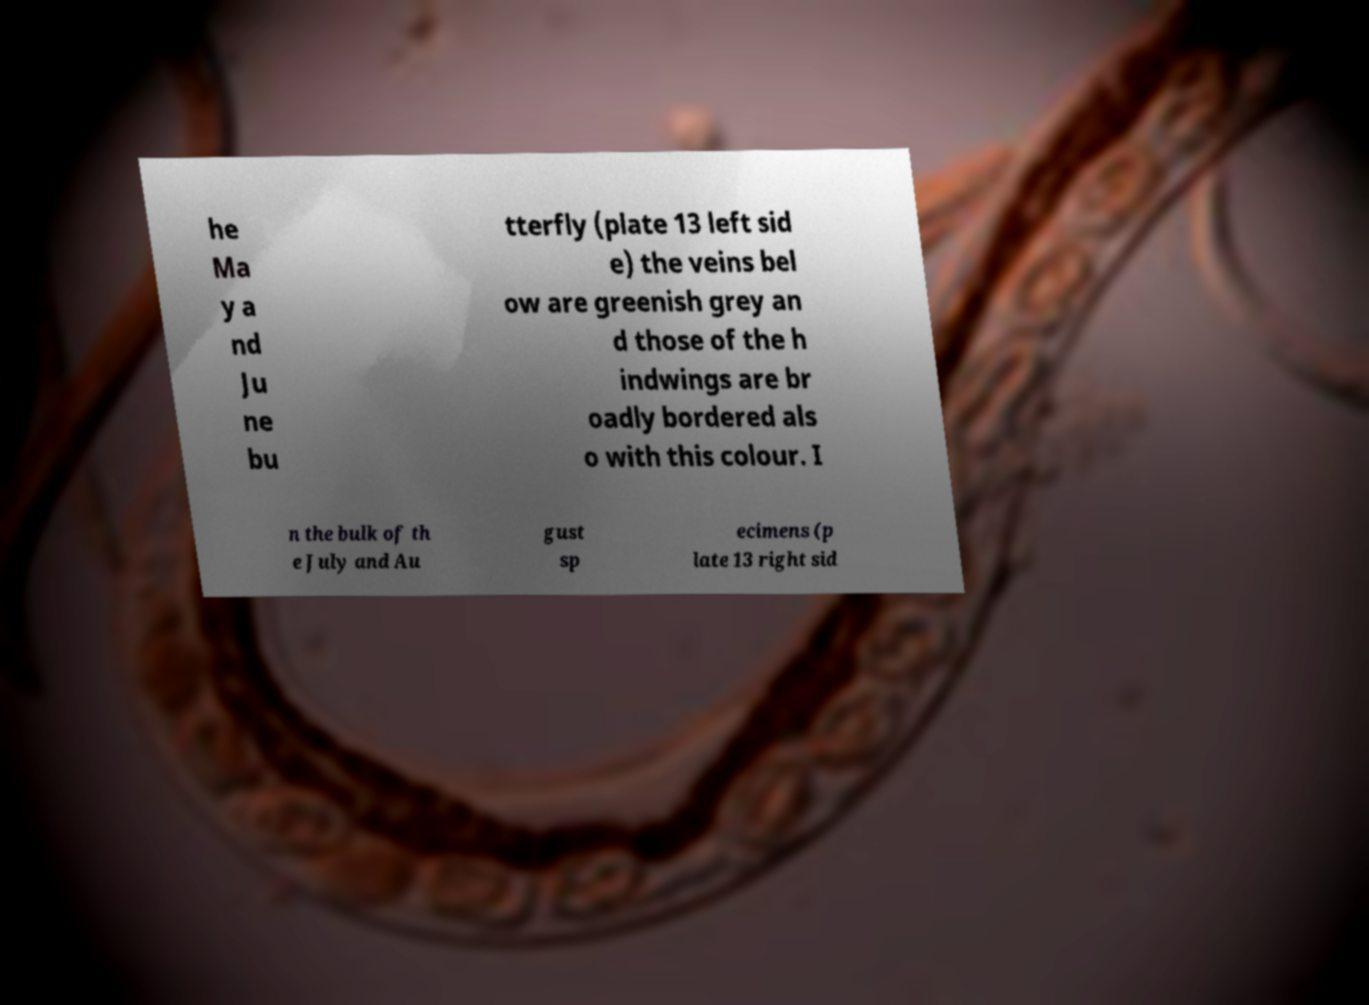I need the written content from this picture converted into text. Can you do that? he Ma y a nd Ju ne bu tterfly (plate 13 left sid e) the veins bel ow are greenish grey an d those of the h indwings are br oadly bordered als o with this colour. I n the bulk of th e July and Au gust sp ecimens (p late 13 right sid 